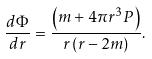<formula> <loc_0><loc_0><loc_500><loc_500>\frac { d \Phi } { d r } = \frac { \left ( m + 4 \pi r ^ { 3 } P \right ) } { r \left ( r - 2 m \right ) } .</formula> 